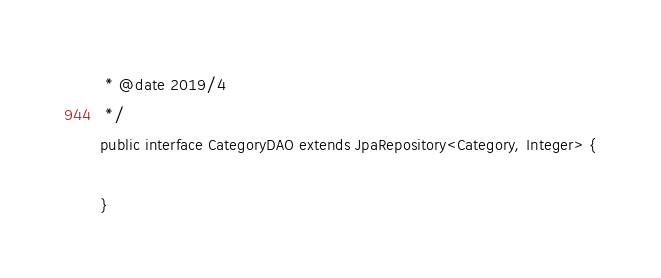<code> <loc_0><loc_0><loc_500><loc_500><_Java_> * @date 2019/4
 */
public interface CategoryDAO extends JpaRepository<Category, Integer> {

}
</code> 